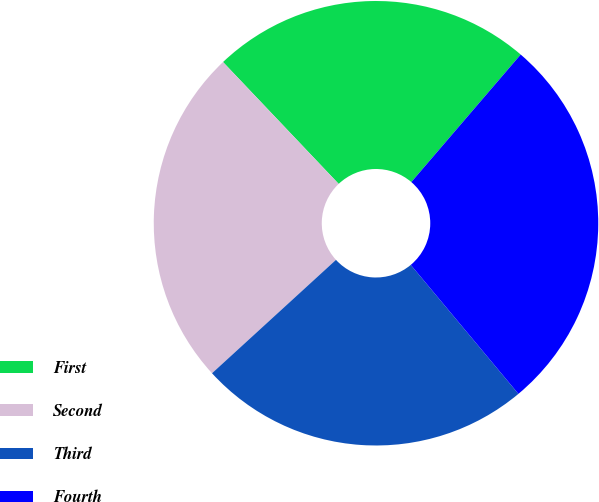<chart> <loc_0><loc_0><loc_500><loc_500><pie_chart><fcel>First<fcel>Second<fcel>Third<fcel>Fourth<nl><fcel>23.37%<fcel>24.71%<fcel>24.28%<fcel>27.65%<nl></chart> 